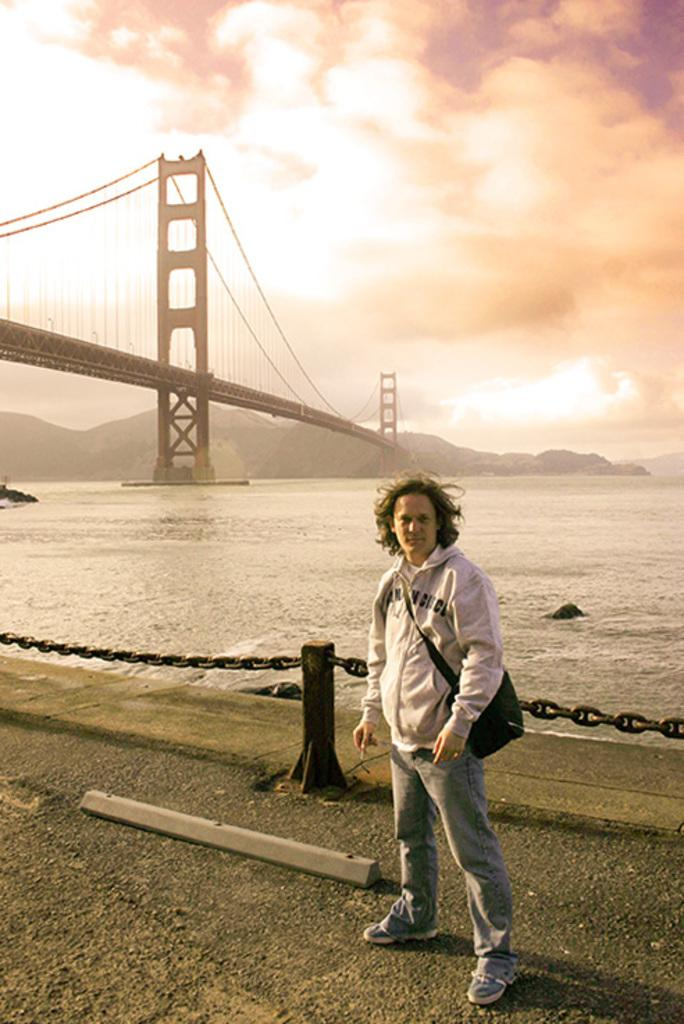What is the main subject of the image? There is a man standing in the image. What is the man wearing? The man is wearing a dress. What can be seen in the background of the image? There is water and a bridge in the image. What is the condition of the sky in the image? The sky is cloudy in the image. How many sheep are visible in the image? There are no sheep present in the image. What type of learning material can be seen in the man's hands? There is no learning material visible in the man's hands, as he is not holding anything. 